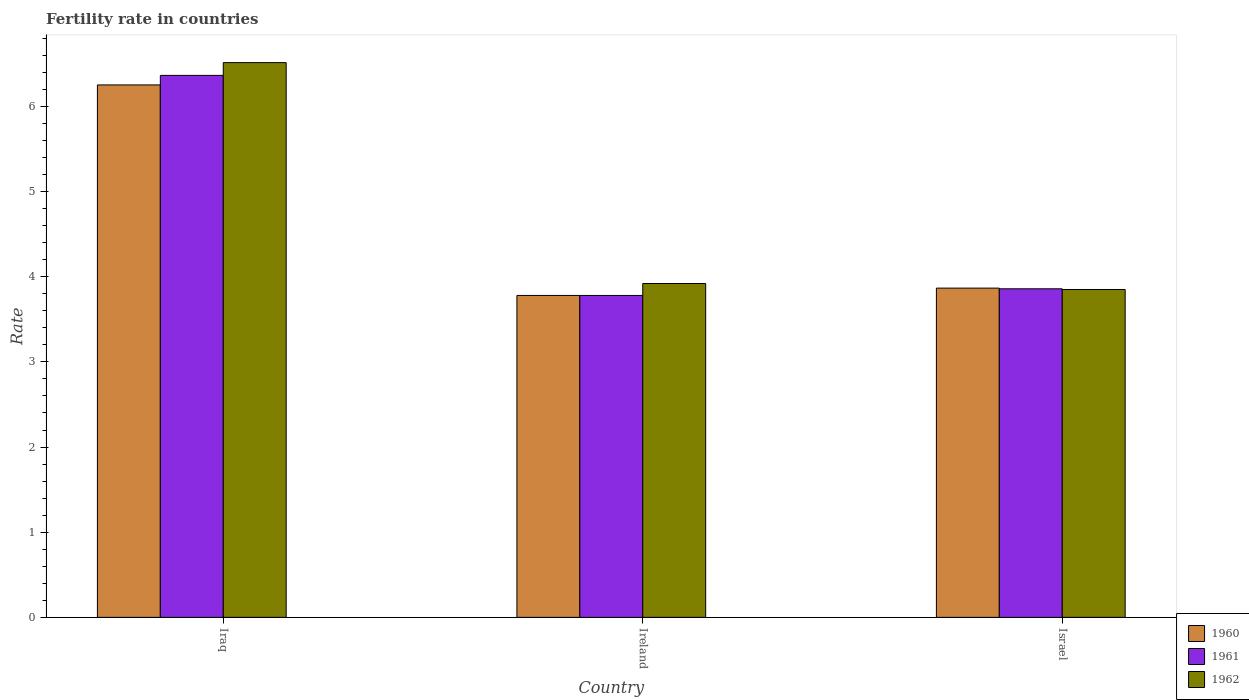How many groups of bars are there?
Your answer should be very brief. 3. Are the number of bars per tick equal to the number of legend labels?
Your answer should be compact. Yes. How many bars are there on the 3rd tick from the left?
Ensure brevity in your answer.  3. What is the label of the 1st group of bars from the left?
Provide a succinct answer. Iraq. What is the fertility rate in 1961 in Israel?
Your answer should be very brief. 3.86. Across all countries, what is the maximum fertility rate in 1962?
Keep it short and to the point. 6.51. Across all countries, what is the minimum fertility rate in 1960?
Keep it short and to the point. 3.78. In which country was the fertility rate in 1962 maximum?
Offer a very short reply. Iraq. In which country was the fertility rate in 1960 minimum?
Make the answer very short. Ireland. What is the total fertility rate in 1961 in the graph?
Give a very brief answer. 14. What is the difference between the fertility rate in 1960 in Iraq and that in Israel?
Offer a terse response. 2.39. What is the difference between the fertility rate in 1961 in Israel and the fertility rate in 1962 in Ireland?
Give a very brief answer. -0.06. What is the average fertility rate in 1962 per country?
Provide a short and direct response. 4.76. What is the difference between the fertility rate of/in 1961 and fertility rate of/in 1960 in Israel?
Offer a terse response. -0.01. What is the ratio of the fertility rate in 1960 in Ireland to that in Israel?
Give a very brief answer. 0.98. Is the fertility rate in 1962 in Iraq less than that in Israel?
Make the answer very short. No. Is the difference between the fertility rate in 1961 in Ireland and Israel greater than the difference between the fertility rate in 1960 in Ireland and Israel?
Make the answer very short. Yes. What is the difference between the highest and the second highest fertility rate in 1962?
Give a very brief answer. -0.07. What is the difference between the highest and the lowest fertility rate in 1960?
Keep it short and to the point. 2.47. In how many countries, is the fertility rate in 1962 greater than the average fertility rate in 1962 taken over all countries?
Offer a terse response. 1. What does the 2nd bar from the left in Ireland represents?
Make the answer very short. 1961. What does the 2nd bar from the right in Iraq represents?
Give a very brief answer. 1961. How many bars are there?
Give a very brief answer. 9. Are all the bars in the graph horizontal?
Keep it short and to the point. No. Does the graph contain any zero values?
Give a very brief answer. No. Does the graph contain grids?
Your answer should be compact. No. What is the title of the graph?
Ensure brevity in your answer.  Fertility rate in countries. Does "1965" appear as one of the legend labels in the graph?
Provide a succinct answer. No. What is the label or title of the X-axis?
Give a very brief answer. Country. What is the label or title of the Y-axis?
Keep it short and to the point. Rate. What is the Rate of 1960 in Iraq?
Provide a short and direct response. 6.25. What is the Rate in 1961 in Iraq?
Make the answer very short. 6.36. What is the Rate in 1962 in Iraq?
Your answer should be very brief. 6.51. What is the Rate of 1960 in Ireland?
Ensure brevity in your answer.  3.78. What is the Rate in 1961 in Ireland?
Provide a short and direct response. 3.78. What is the Rate of 1962 in Ireland?
Give a very brief answer. 3.92. What is the Rate in 1960 in Israel?
Make the answer very short. 3.87. What is the Rate of 1961 in Israel?
Offer a terse response. 3.86. What is the Rate of 1962 in Israel?
Make the answer very short. 3.85. Across all countries, what is the maximum Rate of 1960?
Ensure brevity in your answer.  6.25. Across all countries, what is the maximum Rate in 1961?
Your answer should be compact. 6.36. Across all countries, what is the maximum Rate in 1962?
Give a very brief answer. 6.51. Across all countries, what is the minimum Rate in 1960?
Your response must be concise. 3.78. Across all countries, what is the minimum Rate of 1961?
Provide a short and direct response. 3.78. Across all countries, what is the minimum Rate in 1962?
Make the answer very short. 3.85. What is the total Rate of 1960 in the graph?
Make the answer very short. 13.9. What is the total Rate of 1961 in the graph?
Keep it short and to the point. 14. What is the total Rate of 1962 in the graph?
Your answer should be very brief. 14.28. What is the difference between the Rate in 1960 in Iraq and that in Ireland?
Offer a very short reply. 2.47. What is the difference between the Rate in 1961 in Iraq and that in Ireland?
Ensure brevity in your answer.  2.58. What is the difference between the Rate of 1962 in Iraq and that in Ireland?
Offer a terse response. 2.59. What is the difference between the Rate in 1960 in Iraq and that in Israel?
Your response must be concise. 2.39. What is the difference between the Rate in 1961 in Iraq and that in Israel?
Your response must be concise. 2.51. What is the difference between the Rate in 1962 in Iraq and that in Israel?
Offer a very short reply. 2.66. What is the difference between the Rate in 1960 in Ireland and that in Israel?
Make the answer very short. -0.09. What is the difference between the Rate of 1961 in Ireland and that in Israel?
Make the answer very short. -0.08. What is the difference between the Rate of 1962 in Ireland and that in Israel?
Your response must be concise. 0.07. What is the difference between the Rate of 1960 in Iraq and the Rate of 1961 in Ireland?
Your response must be concise. 2.47. What is the difference between the Rate of 1960 in Iraq and the Rate of 1962 in Ireland?
Your answer should be very brief. 2.33. What is the difference between the Rate in 1961 in Iraq and the Rate in 1962 in Ireland?
Your answer should be very brief. 2.44. What is the difference between the Rate of 1960 in Iraq and the Rate of 1961 in Israel?
Ensure brevity in your answer.  2.39. What is the difference between the Rate in 1960 in Iraq and the Rate in 1962 in Israel?
Make the answer very short. 2.4. What is the difference between the Rate in 1961 in Iraq and the Rate in 1962 in Israel?
Provide a succinct answer. 2.51. What is the difference between the Rate of 1960 in Ireland and the Rate of 1961 in Israel?
Provide a short and direct response. -0.08. What is the difference between the Rate in 1960 in Ireland and the Rate in 1962 in Israel?
Your answer should be very brief. -0.07. What is the difference between the Rate of 1961 in Ireland and the Rate of 1962 in Israel?
Ensure brevity in your answer.  -0.07. What is the average Rate of 1960 per country?
Provide a short and direct response. 4.63. What is the average Rate of 1961 per country?
Provide a short and direct response. 4.67. What is the average Rate in 1962 per country?
Your response must be concise. 4.76. What is the difference between the Rate in 1960 and Rate in 1961 in Iraq?
Offer a terse response. -0.11. What is the difference between the Rate in 1960 and Rate in 1962 in Iraq?
Your answer should be compact. -0.26. What is the difference between the Rate of 1961 and Rate of 1962 in Iraq?
Your answer should be very brief. -0.15. What is the difference between the Rate in 1960 and Rate in 1961 in Ireland?
Your answer should be very brief. 0. What is the difference between the Rate of 1960 and Rate of 1962 in Ireland?
Make the answer very short. -0.14. What is the difference between the Rate in 1961 and Rate in 1962 in Ireland?
Your answer should be very brief. -0.14. What is the difference between the Rate of 1960 and Rate of 1961 in Israel?
Offer a terse response. 0.01. What is the difference between the Rate in 1960 and Rate in 1962 in Israel?
Provide a short and direct response. 0.02. What is the difference between the Rate in 1961 and Rate in 1962 in Israel?
Provide a succinct answer. 0.01. What is the ratio of the Rate of 1960 in Iraq to that in Ireland?
Your answer should be very brief. 1.65. What is the ratio of the Rate of 1961 in Iraq to that in Ireland?
Offer a very short reply. 1.68. What is the ratio of the Rate in 1962 in Iraq to that in Ireland?
Your answer should be very brief. 1.66. What is the ratio of the Rate of 1960 in Iraq to that in Israel?
Give a very brief answer. 1.62. What is the ratio of the Rate of 1961 in Iraq to that in Israel?
Make the answer very short. 1.65. What is the ratio of the Rate of 1962 in Iraq to that in Israel?
Give a very brief answer. 1.69. What is the ratio of the Rate in 1960 in Ireland to that in Israel?
Ensure brevity in your answer.  0.98. What is the ratio of the Rate in 1961 in Ireland to that in Israel?
Make the answer very short. 0.98. What is the ratio of the Rate of 1962 in Ireland to that in Israel?
Keep it short and to the point. 1.02. What is the difference between the highest and the second highest Rate in 1960?
Your answer should be compact. 2.39. What is the difference between the highest and the second highest Rate of 1961?
Keep it short and to the point. 2.51. What is the difference between the highest and the second highest Rate of 1962?
Keep it short and to the point. 2.59. What is the difference between the highest and the lowest Rate of 1960?
Ensure brevity in your answer.  2.47. What is the difference between the highest and the lowest Rate in 1961?
Your answer should be very brief. 2.58. What is the difference between the highest and the lowest Rate in 1962?
Your response must be concise. 2.66. 